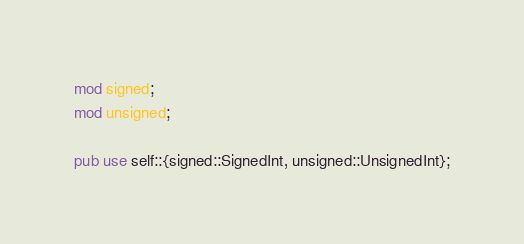<code> <loc_0><loc_0><loc_500><loc_500><_Rust_>mod signed;
mod unsigned;

pub use self::{signed::SignedInt, unsigned::UnsignedInt};
</code> 